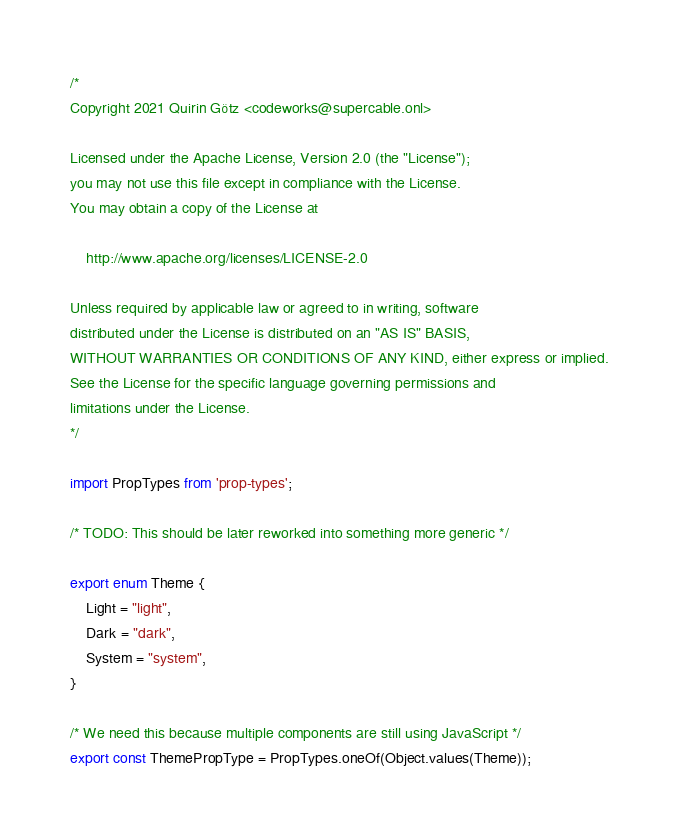Convert code to text. <code><loc_0><loc_0><loc_500><loc_500><_TypeScript_>/*
Copyright 2021 Quirin Götz <codeworks@supercable.onl>

Licensed under the Apache License, Version 2.0 (the "License");
you may not use this file except in compliance with the License.
You may obtain a copy of the License at

    http://www.apache.org/licenses/LICENSE-2.0

Unless required by applicable law or agreed to in writing, software
distributed under the License is distributed on an "AS IS" BASIS,
WITHOUT WARRANTIES OR CONDITIONS OF ANY KIND, either express or implied.
See the License for the specific language governing permissions and
limitations under the License.
*/

import PropTypes from 'prop-types';

/* TODO: This should be later reworked into something more generic */

export enum Theme {
    Light = "light",
    Dark = "dark",
    System = "system",
}

/* We need this because multiple components are still using JavaScript */
export const ThemePropType = PropTypes.oneOf(Object.values(Theme));
</code> 